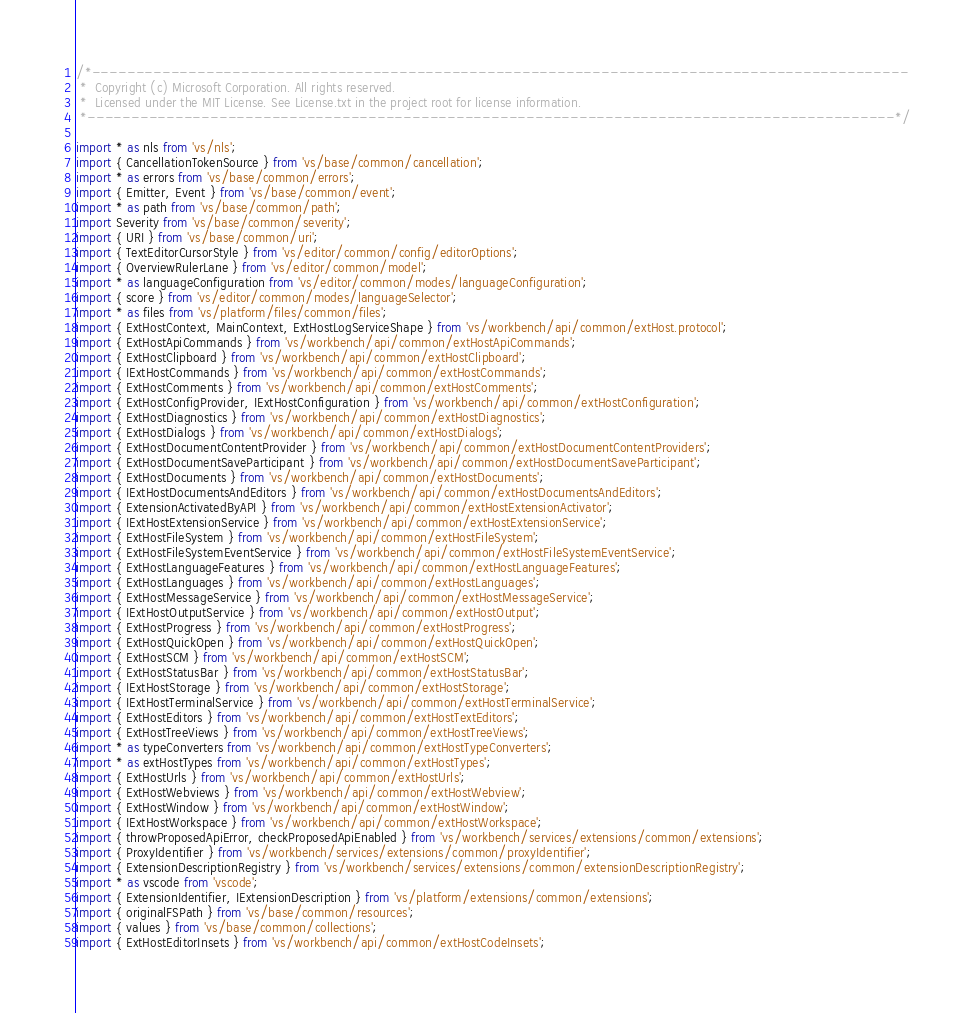Convert code to text. <code><loc_0><loc_0><loc_500><loc_500><_TypeScript_>/*---------------------------------------------------------------------------------------------
 *  Copyright (c) Microsoft Corporation. All rights reserved.
 *  Licensed under the MIT License. See License.txt in the project root for license information.
 *--------------------------------------------------------------------------------------------*/

import * as nls from 'vs/nls';
import { CancellationTokenSource } from 'vs/base/common/cancellation';
import * as errors from 'vs/base/common/errors';
import { Emitter, Event } from 'vs/base/common/event';
import * as path from 'vs/base/common/path';
import Severity from 'vs/base/common/severity';
import { URI } from 'vs/base/common/uri';
import { TextEditorCursorStyle } from 'vs/editor/common/config/editorOptions';
import { OverviewRulerLane } from 'vs/editor/common/model';
import * as languageConfiguration from 'vs/editor/common/modes/languageConfiguration';
import { score } from 'vs/editor/common/modes/languageSelector';
import * as files from 'vs/platform/files/common/files';
import { ExtHostContext, MainContext, ExtHostLogServiceShape } from 'vs/workbench/api/common/extHost.protocol';
import { ExtHostApiCommands } from 'vs/workbench/api/common/extHostApiCommands';
import { ExtHostClipboard } from 'vs/workbench/api/common/extHostClipboard';
import { IExtHostCommands } from 'vs/workbench/api/common/extHostCommands';
import { ExtHostComments } from 'vs/workbench/api/common/extHostComments';
import { ExtHostConfigProvider, IExtHostConfiguration } from 'vs/workbench/api/common/extHostConfiguration';
import { ExtHostDiagnostics } from 'vs/workbench/api/common/extHostDiagnostics';
import { ExtHostDialogs } from 'vs/workbench/api/common/extHostDialogs';
import { ExtHostDocumentContentProvider } from 'vs/workbench/api/common/extHostDocumentContentProviders';
import { ExtHostDocumentSaveParticipant } from 'vs/workbench/api/common/extHostDocumentSaveParticipant';
import { ExtHostDocuments } from 'vs/workbench/api/common/extHostDocuments';
import { IExtHostDocumentsAndEditors } from 'vs/workbench/api/common/extHostDocumentsAndEditors';
import { ExtensionActivatedByAPI } from 'vs/workbench/api/common/extHostExtensionActivator';
import { IExtHostExtensionService } from 'vs/workbench/api/common/extHostExtensionService';
import { ExtHostFileSystem } from 'vs/workbench/api/common/extHostFileSystem';
import { ExtHostFileSystemEventService } from 'vs/workbench/api/common/extHostFileSystemEventService';
import { ExtHostLanguageFeatures } from 'vs/workbench/api/common/extHostLanguageFeatures';
import { ExtHostLanguages } from 'vs/workbench/api/common/extHostLanguages';
import { ExtHostMessageService } from 'vs/workbench/api/common/extHostMessageService';
import { IExtHostOutputService } from 'vs/workbench/api/common/extHostOutput';
import { ExtHostProgress } from 'vs/workbench/api/common/extHostProgress';
import { ExtHostQuickOpen } from 'vs/workbench/api/common/extHostQuickOpen';
import { ExtHostSCM } from 'vs/workbench/api/common/extHostSCM';
import { ExtHostStatusBar } from 'vs/workbench/api/common/extHostStatusBar';
import { IExtHostStorage } from 'vs/workbench/api/common/extHostStorage';
import { IExtHostTerminalService } from 'vs/workbench/api/common/extHostTerminalService';
import { ExtHostEditors } from 'vs/workbench/api/common/extHostTextEditors';
import { ExtHostTreeViews } from 'vs/workbench/api/common/extHostTreeViews';
import * as typeConverters from 'vs/workbench/api/common/extHostTypeConverters';
import * as extHostTypes from 'vs/workbench/api/common/extHostTypes';
import { ExtHostUrls } from 'vs/workbench/api/common/extHostUrls';
import { ExtHostWebviews } from 'vs/workbench/api/common/extHostWebview';
import { ExtHostWindow } from 'vs/workbench/api/common/extHostWindow';
import { IExtHostWorkspace } from 'vs/workbench/api/common/extHostWorkspace';
import { throwProposedApiError, checkProposedApiEnabled } from 'vs/workbench/services/extensions/common/extensions';
import { ProxyIdentifier } from 'vs/workbench/services/extensions/common/proxyIdentifier';
import { ExtensionDescriptionRegistry } from 'vs/workbench/services/extensions/common/extensionDescriptionRegistry';
import * as vscode from 'vscode';
import { ExtensionIdentifier, IExtensionDescription } from 'vs/platform/extensions/common/extensions';
import { originalFSPath } from 'vs/base/common/resources';
import { values } from 'vs/base/common/collections';
import { ExtHostEditorInsets } from 'vs/workbench/api/common/extHostCodeInsets';</code> 